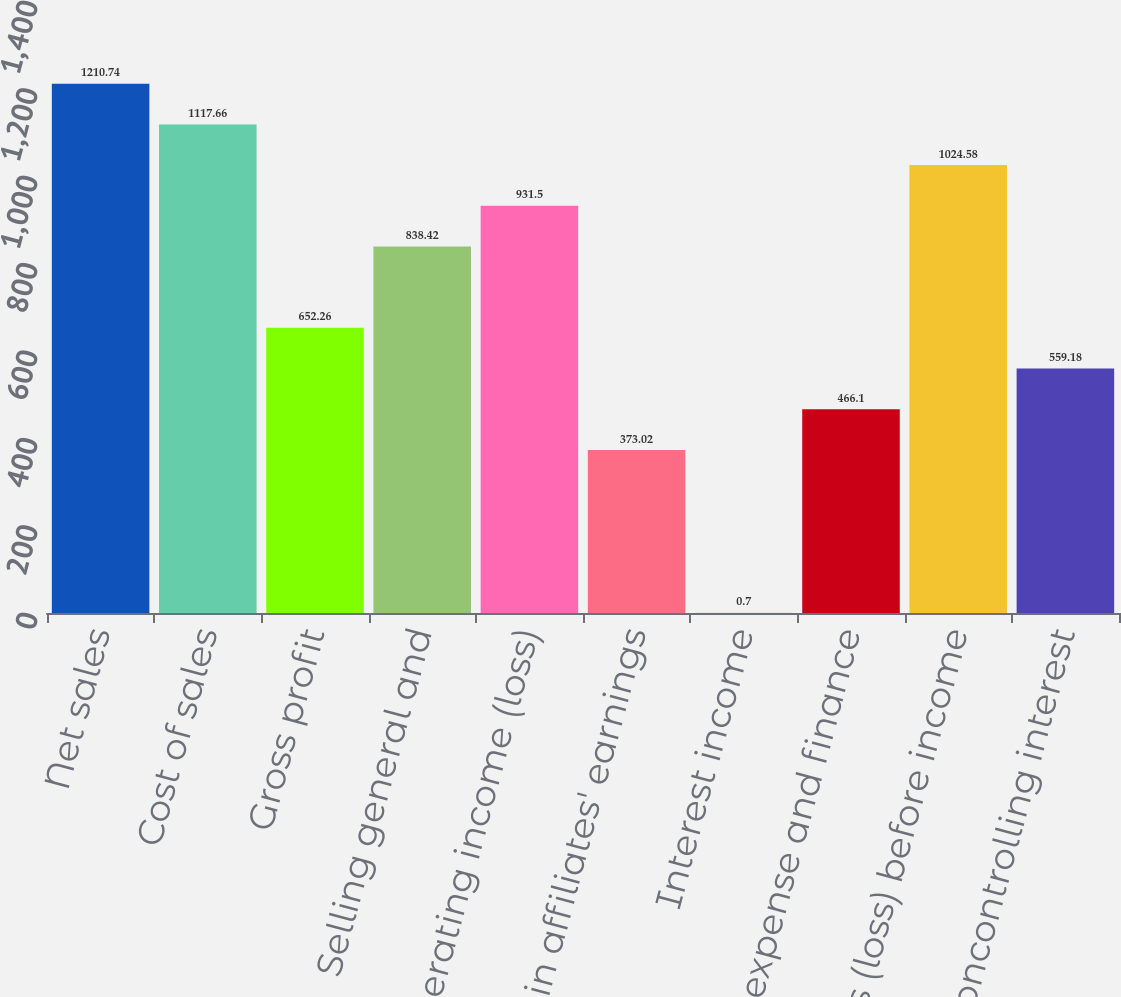<chart> <loc_0><loc_0><loc_500><loc_500><bar_chart><fcel>Net sales<fcel>Cost of sales<fcel>Gross profit<fcel>Selling general and<fcel>Operating income (loss)<fcel>Equity in affiliates' earnings<fcel>Interest income<fcel>Interest expense and finance<fcel>Earnings (loss) before income<fcel>noncontrolling interest<nl><fcel>1210.74<fcel>1117.66<fcel>652.26<fcel>838.42<fcel>931.5<fcel>373.02<fcel>0.7<fcel>466.1<fcel>1024.58<fcel>559.18<nl></chart> 